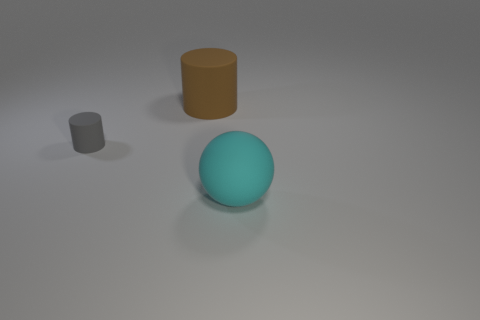Is there anything else that has the same size as the gray matte object?
Offer a very short reply. No. There is a big object that is on the right side of the brown cylinder; what is it made of?
Make the answer very short. Rubber. There is another object that is the same size as the cyan object; what is its material?
Your answer should be very brief. Rubber. The big object behind the large matte object in front of the big object that is to the left of the cyan rubber object is made of what material?
Your answer should be very brief. Rubber. Do the cyan sphere that is right of the brown matte thing and the large brown cylinder have the same size?
Make the answer very short. Yes. Is the number of large metal blocks greater than the number of tiny gray cylinders?
Make the answer very short. No. How many tiny objects are brown rubber cylinders or gray things?
Give a very brief answer. 1. What number of other objects are there of the same color as the big rubber cylinder?
Give a very brief answer. 0. What number of brown balls have the same material as the big brown thing?
Provide a short and direct response. 0. How many brown objects are matte objects or cylinders?
Make the answer very short. 1. 